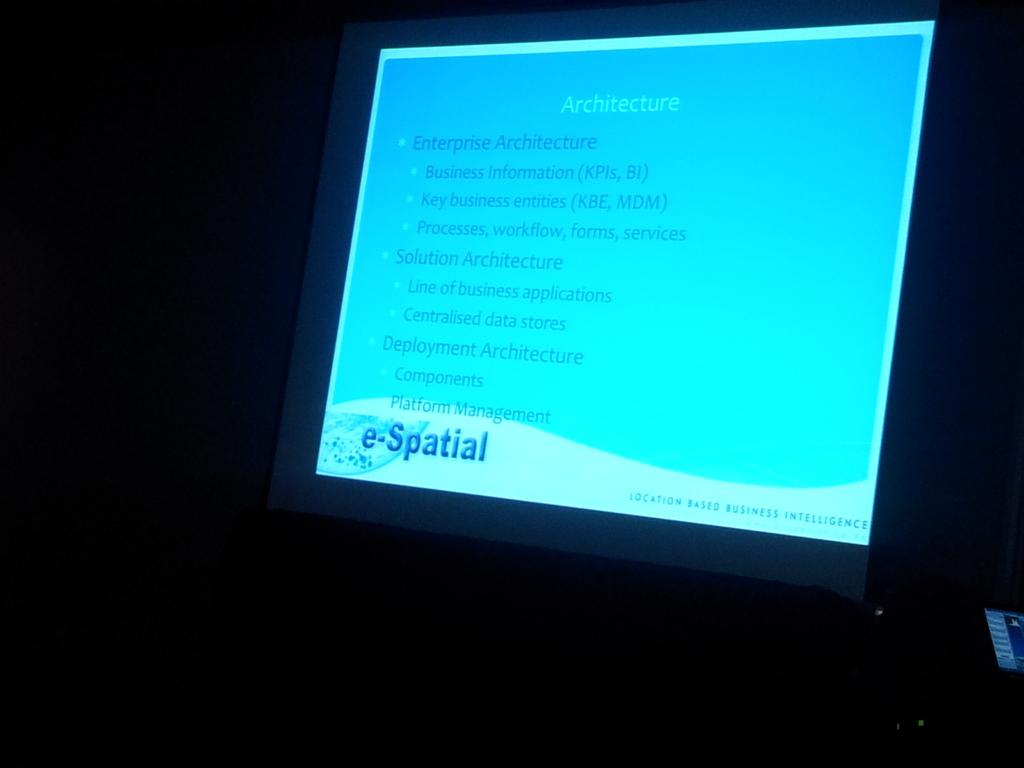<image>
Render a clear and concise summary of the photo. A computer monitor says e-Spatial in the lower left corner. 